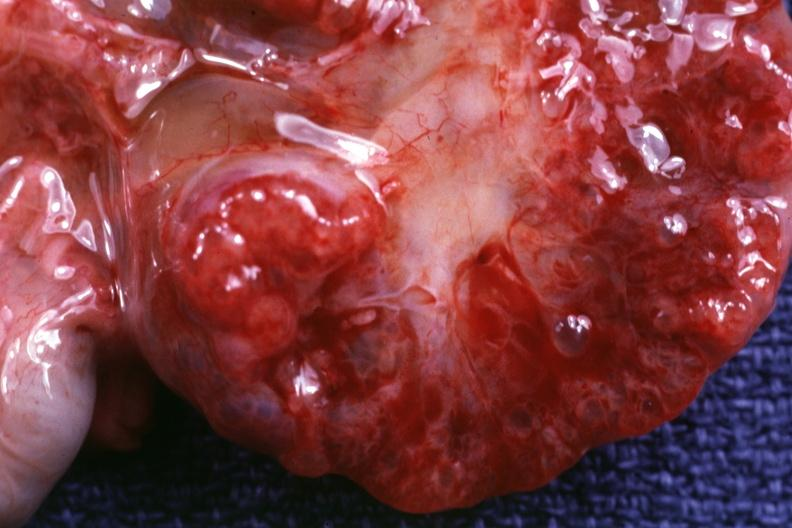what is present?
Answer the question using a single word or phrase. Polycystic disease infant 